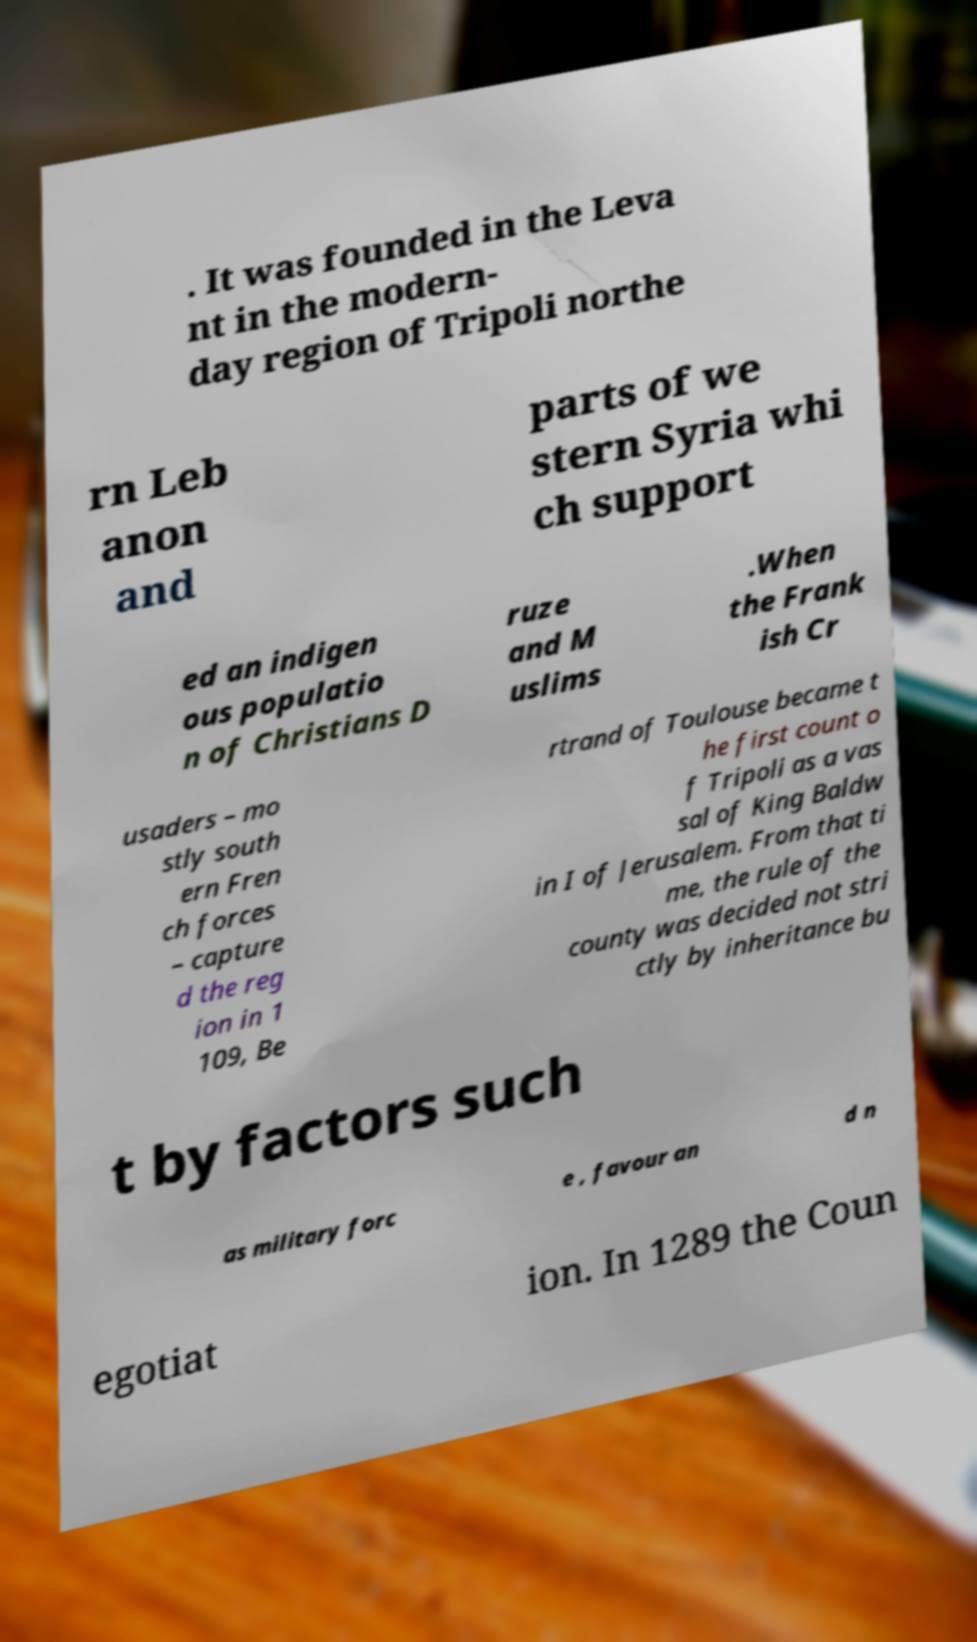Can you read and provide the text displayed in the image?This photo seems to have some interesting text. Can you extract and type it out for me? . It was founded in the Leva nt in the modern- day region of Tripoli northe rn Leb anon and parts of we stern Syria whi ch support ed an indigen ous populatio n of Christians D ruze and M uslims .When the Frank ish Cr usaders – mo stly south ern Fren ch forces – capture d the reg ion in 1 109, Be rtrand of Toulouse became t he first count o f Tripoli as a vas sal of King Baldw in I of Jerusalem. From that ti me, the rule of the county was decided not stri ctly by inheritance bu t by factors such as military forc e , favour an d n egotiat ion. In 1289 the Coun 